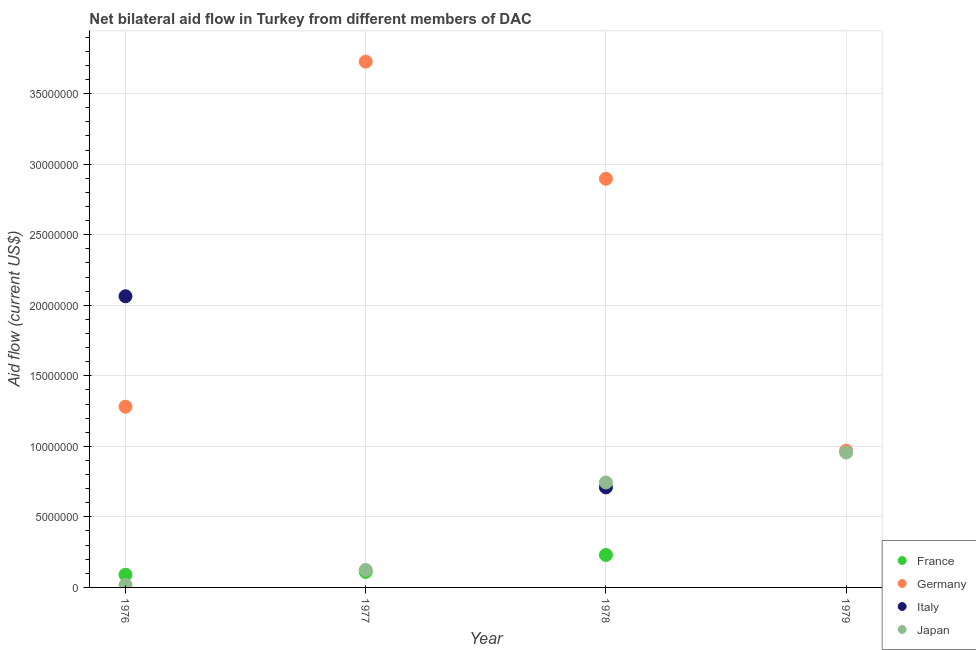How many different coloured dotlines are there?
Your answer should be very brief. 4. Is the number of dotlines equal to the number of legend labels?
Offer a terse response. No. What is the amount of aid given by germany in 1977?
Your response must be concise. 3.73e+07. Across all years, what is the maximum amount of aid given by france?
Offer a terse response. 2.30e+06. Across all years, what is the minimum amount of aid given by france?
Your response must be concise. 0. In which year was the amount of aid given by france maximum?
Offer a terse response. 1978. What is the total amount of aid given by germany in the graph?
Ensure brevity in your answer.  8.87e+07. What is the difference between the amount of aid given by germany in 1976 and that in 1978?
Give a very brief answer. -1.62e+07. What is the difference between the amount of aid given by germany in 1978 and the amount of aid given by japan in 1977?
Offer a very short reply. 2.77e+07. What is the average amount of aid given by france per year?
Give a very brief answer. 1.08e+06. In the year 1977, what is the difference between the amount of aid given by japan and amount of aid given by germany?
Your answer should be very brief. -3.60e+07. In how many years, is the amount of aid given by japan greater than 17000000 US$?
Your response must be concise. 0. What is the ratio of the amount of aid given by germany in 1978 to that in 1979?
Make the answer very short. 2.99. Is the amount of aid given by germany in 1978 less than that in 1979?
Offer a very short reply. No. What is the difference between the highest and the second highest amount of aid given by japan?
Provide a succinct answer. 2.12e+06. What is the difference between the highest and the lowest amount of aid given by italy?
Offer a terse response. 2.06e+07. Is the sum of the amount of aid given by japan in 1977 and 1978 greater than the maximum amount of aid given by france across all years?
Give a very brief answer. Yes. Is it the case that in every year, the sum of the amount of aid given by france and amount of aid given by germany is greater than the amount of aid given by italy?
Your answer should be very brief. No. Does the amount of aid given by germany monotonically increase over the years?
Your answer should be compact. No. How many years are there in the graph?
Your response must be concise. 4. What is the difference between two consecutive major ticks on the Y-axis?
Your response must be concise. 5.00e+06. Are the values on the major ticks of Y-axis written in scientific E-notation?
Ensure brevity in your answer.  No. Does the graph contain any zero values?
Ensure brevity in your answer.  Yes. Does the graph contain grids?
Your response must be concise. Yes. What is the title of the graph?
Offer a very short reply. Net bilateral aid flow in Turkey from different members of DAC. Does "WHO" appear as one of the legend labels in the graph?
Your response must be concise. No. What is the label or title of the X-axis?
Keep it short and to the point. Year. What is the label or title of the Y-axis?
Ensure brevity in your answer.  Aid flow (current US$). What is the Aid flow (current US$) in Germany in 1976?
Provide a succinct answer. 1.28e+07. What is the Aid flow (current US$) of Italy in 1976?
Your response must be concise. 2.06e+07. What is the Aid flow (current US$) of France in 1977?
Provide a short and direct response. 1.10e+06. What is the Aid flow (current US$) in Germany in 1977?
Ensure brevity in your answer.  3.73e+07. What is the Aid flow (current US$) of Italy in 1977?
Make the answer very short. 0. What is the Aid flow (current US$) in Japan in 1977?
Give a very brief answer. 1.24e+06. What is the Aid flow (current US$) of France in 1978?
Ensure brevity in your answer.  2.30e+06. What is the Aid flow (current US$) in Germany in 1978?
Offer a very short reply. 2.90e+07. What is the Aid flow (current US$) of Italy in 1978?
Give a very brief answer. 7.09e+06. What is the Aid flow (current US$) of Japan in 1978?
Your response must be concise. 7.44e+06. What is the Aid flow (current US$) of France in 1979?
Give a very brief answer. 0. What is the Aid flow (current US$) of Germany in 1979?
Make the answer very short. 9.69e+06. What is the Aid flow (current US$) of Italy in 1979?
Provide a short and direct response. 0. What is the Aid flow (current US$) of Japan in 1979?
Your response must be concise. 9.56e+06. Across all years, what is the maximum Aid flow (current US$) in France?
Provide a short and direct response. 2.30e+06. Across all years, what is the maximum Aid flow (current US$) in Germany?
Provide a short and direct response. 3.73e+07. Across all years, what is the maximum Aid flow (current US$) of Italy?
Provide a short and direct response. 2.06e+07. Across all years, what is the maximum Aid flow (current US$) in Japan?
Your answer should be compact. 9.56e+06. Across all years, what is the minimum Aid flow (current US$) in Germany?
Offer a very short reply. 9.69e+06. Across all years, what is the minimum Aid flow (current US$) in Japan?
Give a very brief answer. 1.80e+05. What is the total Aid flow (current US$) in France in the graph?
Give a very brief answer. 4.30e+06. What is the total Aid flow (current US$) of Germany in the graph?
Provide a succinct answer. 8.87e+07. What is the total Aid flow (current US$) of Italy in the graph?
Give a very brief answer. 2.77e+07. What is the total Aid flow (current US$) in Japan in the graph?
Provide a succinct answer. 1.84e+07. What is the difference between the Aid flow (current US$) of Germany in 1976 and that in 1977?
Offer a very short reply. -2.45e+07. What is the difference between the Aid flow (current US$) of Japan in 1976 and that in 1977?
Ensure brevity in your answer.  -1.06e+06. What is the difference between the Aid flow (current US$) of France in 1976 and that in 1978?
Offer a very short reply. -1.40e+06. What is the difference between the Aid flow (current US$) of Germany in 1976 and that in 1978?
Provide a short and direct response. -1.62e+07. What is the difference between the Aid flow (current US$) in Italy in 1976 and that in 1978?
Give a very brief answer. 1.36e+07. What is the difference between the Aid flow (current US$) of Japan in 1976 and that in 1978?
Provide a succinct answer. -7.26e+06. What is the difference between the Aid flow (current US$) of Germany in 1976 and that in 1979?
Ensure brevity in your answer.  3.12e+06. What is the difference between the Aid flow (current US$) of Japan in 1976 and that in 1979?
Your answer should be very brief. -9.38e+06. What is the difference between the Aid flow (current US$) of France in 1977 and that in 1978?
Make the answer very short. -1.20e+06. What is the difference between the Aid flow (current US$) of Germany in 1977 and that in 1978?
Make the answer very short. 8.30e+06. What is the difference between the Aid flow (current US$) of Japan in 1977 and that in 1978?
Give a very brief answer. -6.20e+06. What is the difference between the Aid flow (current US$) of Germany in 1977 and that in 1979?
Ensure brevity in your answer.  2.76e+07. What is the difference between the Aid flow (current US$) of Japan in 1977 and that in 1979?
Make the answer very short. -8.32e+06. What is the difference between the Aid flow (current US$) of Germany in 1978 and that in 1979?
Offer a terse response. 1.93e+07. What is the difference between the Aid flow (current US$) in Japan in 1978 and that in 1979?
Ensure brevity in your answer.  -2.12e+06. What is the difference between the Aid flow (current US$) of France in 1976 and the Aid flow (current US$) of Germany in 1977?
Your response must be concise. -3.64e+07. What is the difference between the Aid flow (current US$) of Germany in 1976 and the Aid flow (current US$) of Japan in 1977?
Your answer should be very brief. 1.16e+07. What is the difference between the Aid flow (current US$) of Italy in 1976 and the Aid flow (current US$) of Japan in 1977?
Give a very brief answer. 1.94e+07. What is the difference between the Aid flow (current US$) in France in 1976 and the Aid flow (current US$) in Germany in 1978?
Give a very brief answer. -2.81e+07. What is the difference between the Aid flow (current US$) in France in 1976 and the Aid flow (current US$) in Italy in 1978?
Keep it short and to the point. -6.19e+06. What is the difference between the Aid flow (current US$) in France in 1976 and the Aid flow (current US$) in Japan in 1978?
Make the answer very short. -6.54e+06. What is the difference between the Aid flow (current US$) in Germany in 1976 and the Aid flow (current US$) in Italy in 1978?
Give a very brief answer. 5.72e+06. What is the difference between the Aid flow (current US$) in Germany in 1976 and the Aid flow (current US$) in Japan in 1978?
Your response must be concise. 5.37e+06. What is the difference between the Aid flow (current US$) of Italy in 1976 and the Aid flow (current US$) of Japan in 1978?
Offer a very short reply. 1.32e+07. What is the difference between the Aid flow (current US$) in France in 1976 and the Aid flow (current US$) in Germany in 1979?
Ensure brevity in your answer.  -8.79e+06. What is the difference between the Aid flow (current US$) in France in 1976 and the Aid flow (current US$) in Japan in 1979?
Provide a succinct answer. -8.66e+06. What is the difference between the Aid flow (current US$) of Germany in 1976 and the Aid flow (current US$) of Japan in 1979?
Offer a terse response. 3.25e+06. What is the difference between the Aid flow (current US$) in Italy in 1976 and the Aid flow (current US$) in Japan in 1979?
Offer a very short reply. 1.11e+07. What is the difference between the Aid flow (current US$) of France in 1977 and the Aid flow (current US$) of Germany in 1978?
Your response must be concise. -2.79e+07. What is the difference between the Aid flow (current US$) of France in 1977 and the Aid flow (current US$) of Italy in 1978?
Offer a very short reply. -5.99e+06. What is the difference between the Aid flow (current US$) of France in 1977 and the Aid flow (current US$) of Japan in 1978?
Your answer should be very brief. -6.34e+06. What is the difference between the Aid flow (current US$) of Germany in 1977 and the Aid flow (current US$) of Italy in 1978?
Ensure brevity in your answer.  3.02e+07. What is the difference between the Aid flow (current US$) of Germany in 1977 and the Aid flow (current US$) of Japan in 1978?
Offer a terse response. 2.98e+07. What is the difference between the Aid flow (current US$) in France in 1977 and the Aid flow (current US$) in Germany in 1979?
Ensure brevity in your answer.  -8.59e+06. What is the difference between the Aid flow (current US$) of France in 1977 and the Aid flow (current US$) of Japan in 1979?
Give a very brief answer. -8.46e+06. What is the difference between the Aid flow (current US$) in Germany in 1977 and the Aid flow (current US$) in Japan in 1979?
Your answer should be very brief. 2.77e+07. What is the difference between the Aid flow (current US$) in France in 1978 and the Aid flow (current US$) in Germany in 1979?
Your response must be concise. -7.39e+06. What is the difference between the Aid flow (current US$) in France in 1978 and the Aid flow (current US$) in Japan in 1979?
Your response must be concise. -7.26e+06. What is the difference between the Aid flow (current US$) of Germany in 1978 and the Aid flow (current US$) of Japan in 1979?
Make the answer very short. 1.94e+07. What is the difference between the Aid flow (current US$) of Italy in 1978 and the Aid flow (current US$) of Japan in 1979?
Your answer should be very brief. -2.47e+06. What is the average Aid flow (current US$) of France per year?
Provide a short and direct response. 1.08e+06. What is the average Aid flow (current US$) of Germany per year?
Your answer should be compact. 2.22e+07. What is the average Aid flow (current US$) of Italy per year?
Your answer should be very brief. 6.93e+06. What is the average Aid flow (current US$) in Japan per year?
Your response must be concise. 4.60e+06. In the year 1976, what is the difference between the Aid flow (current US$) in France and Aid flow (current US$) in Germany?
Offer a very short reply. -1.19e+07. In the year 1976, what is the difference between the Aid flow (current US$) in France and Aid flow (current US$) in Italy?
Ensure brevity in your answer.  -1.97e+07. In the year 1976, what is the difference between the Aid flow (current US$) in France and Aid flow (current US$) in Japan?
Give a very brief answer. 7.20e+05. In the year 1976, what is the difference between the Aid flow (current US$) in Germany and Aid flow (current US$) in Italy?
Provide a succinct answer. -7.83e+06. In the year 1976, what is the difference between the Aid flow (current US$) in Germany and Aid flow (current US$) in Japan?
Ensure brevity in your answer.  1.26e+07. In the year 1976, what is the difference between the Aid flow (current US$) of Italy and Aid flow (current US$) of Japan?
Your answer should be very brief. 2.05e+07. In the year 1977, what is the difference between the Aid flow (current US$) in France and Aid flow (current US$) in Germany?
Make the answer very short. -3.62e+07. In the year 1977, what is the difference between the Aid flow (current US$) in Germany and Aid flow (current US$) in Japan?
Your answer should be very brief. 3.60e+07. In the year 1978, what is the difference between the Aid flow (current US$) of France and Aid flow (current US$) of Germany?
Provide a succinct answer. -2.67e+07. In the year 1978, what is the difference between the Aid flow (current US$) of France and Aid flow (current US$) of Italy?
Your response must be concise. -4.79e+06. In the year 1978, what is the difference between the Aid flow (current US$) in France and Aid flow (current US$) in Japan?
Provide a succinct answer. -5.14e+06. In the year 1978, what is the difference between the Aid flow (current US$) in Germany and Aid flow (current US$) in Italy?
Ensure brevity in your answer.  2.19e+07. In the year 1978, what is the difference between the Aid flow (current US$) in Germany and Aid flow (current US$) in Japan?
Your response must be concise. 2.15e+07. In the year 1978, what is the difference between the Aid flow (current US$) of Italy and Aid flow (current US$) of Japan?
Ensure brevity in your answer.  -3.50e+05. In the year 1979, what is the difference between the Aid flow (current US$) in Germany and Aid flow (current US$) in Japan?
Provide a succinct answer. 1.30e+05. What is the ratio of the Aid flow (current US$) of France in 1976 to that in 1977?
Offer a terse response. 0.82. What is the ratio of the Aid flow (current US$) in Germany in 1976 to that in 1977?
Ensure brevity in your answer.  0.34. What is the ratio of the Aid flow (current US$) in Japan in 1976 to that in 1977?
Your answer should be compact. 0.15. What is the ratio of the Aid flow (current US$) of France in 1976 to that in 1978?
Provide a short and direct response. 0.39. What is the ratio of the Aid flow (current US$) in Germany in 1976 to that in 1978?
Ensure brevity in your answer.  0.44. What is the ratio of the Aid flow (current US$) in Italy in 1976 to that in 1978?
Your response must be concise. 2.91. What is the ratio of the Aid flow (current US$) of Japan in 1976 to that in 1978?
Offer a terse response. 0.02. What is the ratio of the Aid flow (current US$) of Germany in 1976 to that in 1979?
Provide a succinct answer. 1.32. What is the ratio of the Aid flow (current US$) of Japan in 1976 to that in 1979?
Offer a very short reply. 0.02. What is the ratio of the Aid flow (current US$) in France in 1977 to that in 1978?
Your response must be concise. 0.48. What is the ratio of the Aid flow (current US$) in Germany in 1977 to that in 1978?
Your response must be concise. 1.29. What is the ratio of the Aid flow (current US$) of Japan in 1977 to that in 1978?
Your answer should be very brief. 0.17. What is the ratio of the Aid flow (current US$) of Germany in 1977 to that in 1979?
Keep it short and to the point. 3.85. What is the ratio of the Aid flow (current US$) of Japan in 1977 to that in 1979?
Offer a very short reply. 0.13. What is the ratio of the Aid flow (current US$) of Germany in 1978 to that in 1979?
Offer a terse response. 2.99. What is the ratio of the Aid flow (current US$) in Japan in 1978 to that in 1979?
Your response must be concise. 0.78. What is the difference between the highest and the second highest Aid flow (current US$) of France?
Ensure brevity in your answer.  1.20e+06. What is the difference between the highest and the second highest Aid flow (current US$) in Germany?
Offer a terse response. 8.30e+06. What is the difference between the highest and the second highest Aid flow (current US$) of Japan?
Provide a short and direct response. 2.12e+06. What is the difference between the highest and the lowest Aid flow (current US$) in France?
Your response must be concise. 2.30e+06. What is the difference between the highest and the lowest Aid flow (current US$) of Germany?
Your answer should be very brief. 2.76e+07. What is the difference between the highest and the lowest Aid flow (current US$) in Italy?
Your answer should be compact. 2.06e+07. What is the difference between the highest and the lowest Aid flow (current US$) of Japan?
Your answer should be compact. 9.38e+06. 